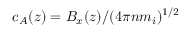Convert formula to latex. <formula><loc_0><loc_0><loc_500><loc_500>c _ { A } ( z ) = B _ { x } ( z ) / ( 4 \pi n m _ { i } ) ^ { 1 / 2 }</formula> 